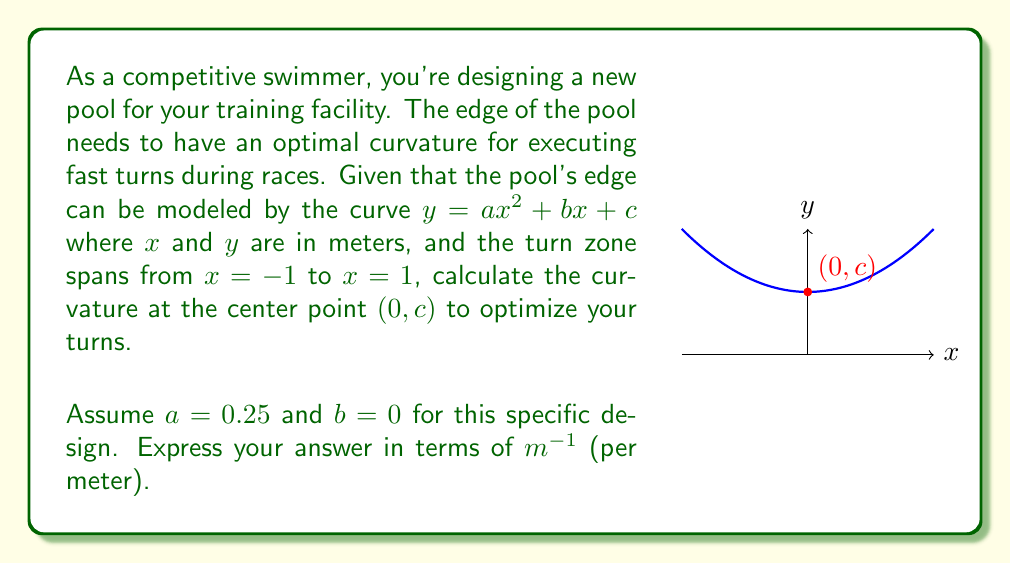Teach me how to tackle this problem. Let's approach this step-by-step:

1) The general formula for curvature $K$ of a curve $y = f(x)$ at any point is:

   $$K = \frac{|f''(x)|}{(1 + [f'(x)]^2)^{3/2}}$$

2) For our curve $y = ax^2 + bx + c$, we need to find $f'(x)$ and $f''(x)$:
   
   $f'(x) = 2ax + b$
   $f''(x) = 2a$

3) We're given that $a = 0.25$ and $b = 0$, so:
   
   $f'(x) = 0.5x$
   $f''(x) = 0.5$

4) We need to calculate the curvature at the center point $(0, c)$, so we'll evaluate at $x = 0$:

   $f'(0) = 0$
   $f''(0) = 0.5$

5) Now, let's substitute these into our curvature formula:

   $$K = \frac{|0.5|}{(1 + [0]^2)^{3/2}} = \frac{0.5}{1} = 0.5$$

6) Therefore, the curvature at the center point is 0.5 m^(-1).
Answer: $0.5 \text{ m}^{-1}$ 